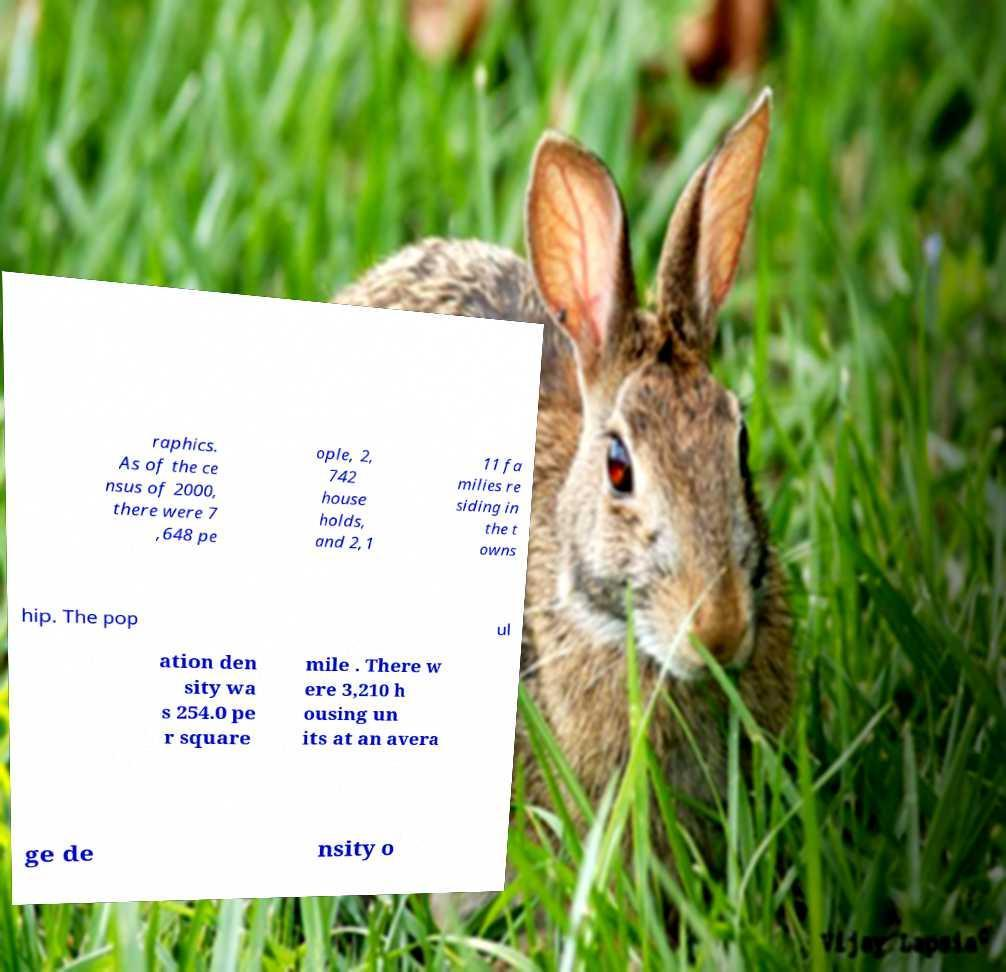What messages or text are displayed in this image? I need them in a readable, typed format. raphics. As of the ce nsus of 2000, there were 7 ,648 pe ople, 2, 742 house holds, and 2,1 11 fa milies re siding in the t owns hip. The pop ul ation den sity wa s 254.0 pe r square mile . There w ere 3,210 h ousing un its at an avera ge de nsity o 